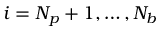Convert formula to latex. <formula><loc_0><loc_0><loc_500><loc_500>i = N _ { p } + 1 , \dots , N _ { b }</formula> 